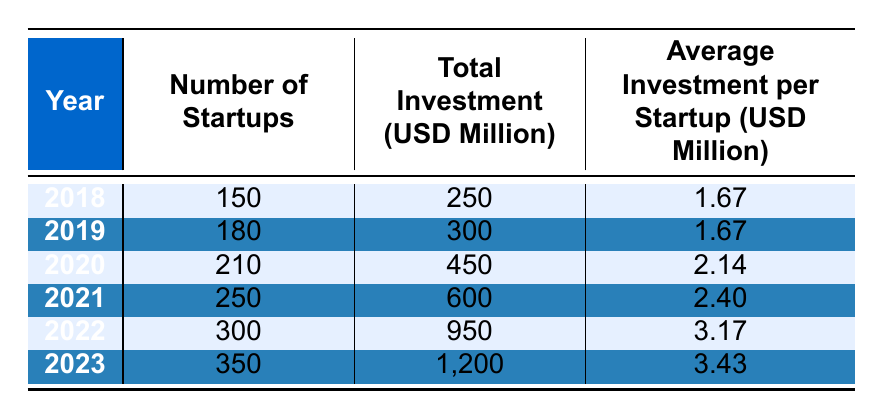What was the total investment in nanotechnology startups in 2021? The table shows that the total investment in 2021 was 600 million USD.
Answer: 600 million USD How many startups were there in 2022? According to the table, there were 300 startups in 2022.
Answer: 300 startups What was the average investment per startup in 2023? The average investment per startup in 2023, as per the table, was 3.43 million USD.
Answer: 3.43 million USD What was the increase in the number of startups from 2018 to 2023? To find the increase, subtract the number of startups in 2018 (150) from the number in 2023 (350). The calculation is 350 - 150 = 200.
Answer: 200 startups Is the average investment per startup in 2020 greater than that in 2019? The table shows that in 2020, the average investment per startup was 2.14 million USD, while in 2019 it was 1.67 million USD. Therefore, the statement is true.
Answer: Yes What was the total investment in nanotechnology startups over the years from 2018 to 2023? The total investment can be calculated by adding the total investments for each year: 250 + 300 + 450 + 600 + 950 + 1200 = 3750 million USD.
Answer: 3750 million USD How much did the average investment per startup increase from 2018 to 2022? The average investment per startup in 2018 was 1.67 million USD, and in 2022 it was 3.17 million USD. The increase is calculated as 3.17 - 1.67 = 1.50 million USD.
Answer: 1.50 million USD What is the total number of startups in the years 2020, 2021, and 2022 combined? The total can be found by adding the number of startups in those years: 210 (2020) + 250 (2021) + 300 (2022) = 760 startups.
Answer: 760 startups In which year was the average investment per startup the highest? The highest average investment per startup is in 2023, which is 3.43 million USD, according to the table.
Answer: 2023 